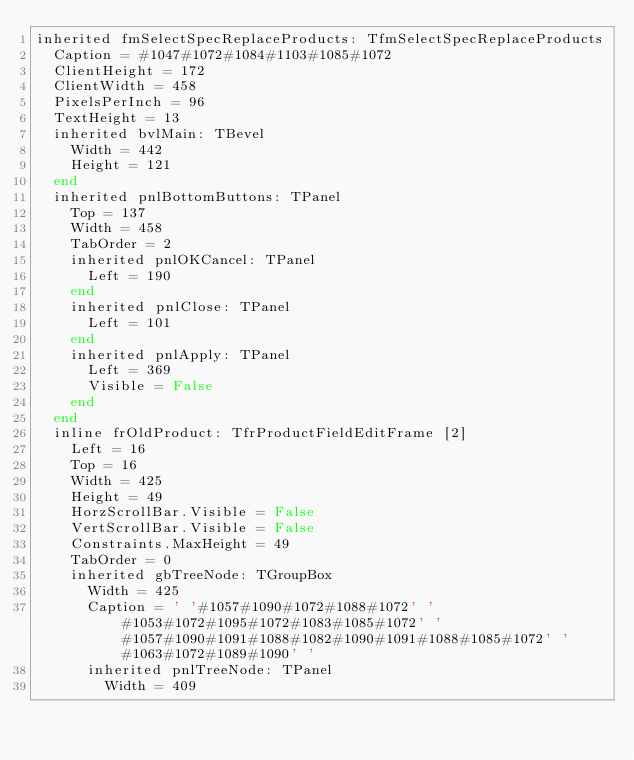Convert code to text. <code><loc_0><loc_0><loc_500><loc_500><_Pascal_>inherited fmSelectSpecReplaceProducts: TfmSelectSpecReplaceProducts
  Caption = #1047#1072#1084#1103#1085#1072
  ClientHeight = 172
  ClientWidth = 458
  PixelsPerInch = 96
  TextHeight = 13
  inherited bvlMain: TBevel
    Width = 442
    Height = 121
  end
  inherited pnlBottomButtons: TPanel
    Top = 137
    Width = 458
    TabOrder = 2
    inherited pnlOKCancel: TPanel
      Left = 190
    end
    inherited pnlClose: TPanel
      Left = 101
    end
    inherited pnlApply: TPanel
      Left = 369
      Visible = False
    end
  end
  inline frOldProduct: TfrProductFieldEditFrame [2]
    Left = 16
    Top = 16
    Width = 425
    Height = 49
    HorzScrollBar.Visible = False
    VertScrollBar.Visible = False
    Constraints.MaxHeight = 49
    TabOrder = 0
    inherited gbTreeNode: TGroupBox
      Width = 425
      Caption = ' '#1057#1090#1072#1088#1072' '#1053#1072#1095#1072#1083#1085#1072' '#1057#1090#1091#1088#1082#1090#1091#1088#1085#1072' '#1063#1072#1089#1090' '
      inherited pnlTreeNode: TPanel
        Width = 409</code> 